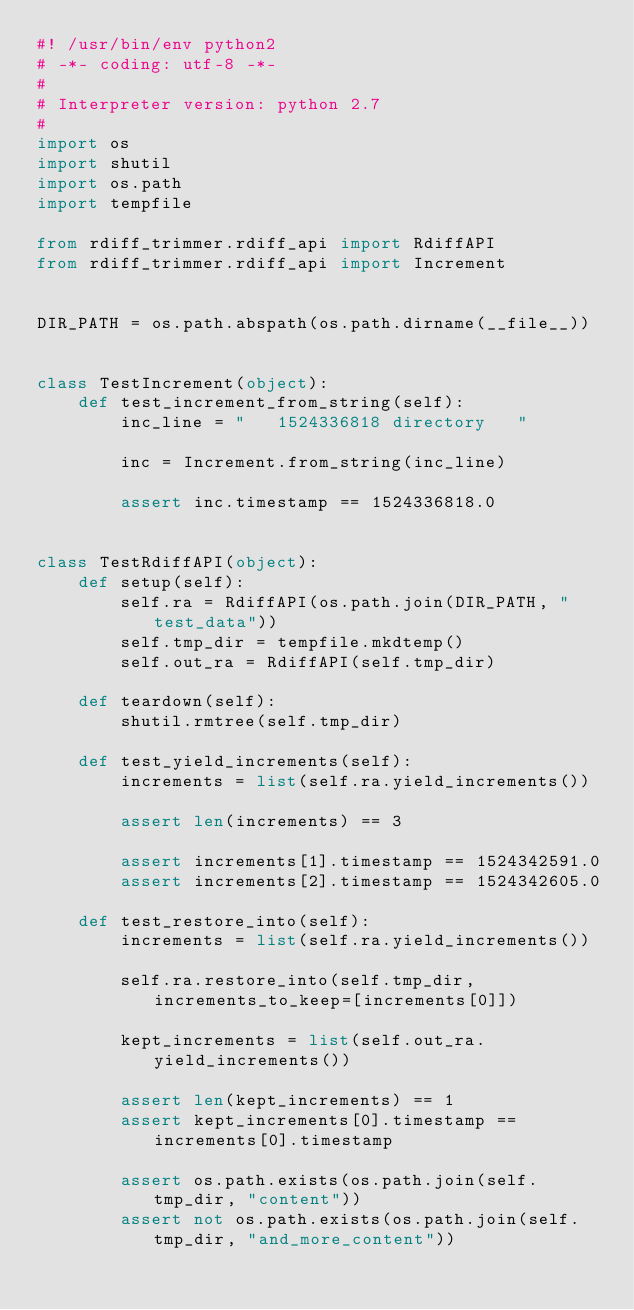<code> <loc_0><loc_0><loc_500><loc_500><_Python_>#! /usr/bin/env python2
# -*- coding: utf-8 -*-
#
# Interpreter version: python 2.7
#
import os
import shutil
import os.path
import tempfile

from rdiff_trimmer.rdiff_api import RdiffAPI
from rdiff_trimmer.rdiff_api import Increment


DIR_PATH = os.path.abspath(os.path.dirname(__file__))


class TestIncrement(object):
    def test_increment_from_string(self):
        inc_line = "   1524336818 directory   "

        inc = Increment.from_string(inc_line)

        assert inc.timestamp == 1524336818.0


class TestRdiffAPI(object):
    def setup(self):
        self.ra = RdiffAPI(os.path.join(DIR_PATH, "test_data"))
        self.tmp_dir = tempfile.mkdtemp()
        self.out_ra = RdiffAPI(self.tmp_dir)

    def teardown(self):
        shutil.rmtree(self.tmp_dir)

    def test_yield_increments(self):
        increments = list(self.ra.yield_increments())

        assert len(increments) == 3

        assert increments[1].timestamp == 1524342591.0
        assert increments[2].timestamp == 1524342605.0

    def test_restore_into(self):
        increments = list(self.ra.yield_increments())

        self.ra.restore_into(self.tmp_dir, increments_to_keep=[increments[0]])

        kept_increments = list(self.out_ra.yield_increments())

        assert len(kept_increments) == 1
        assert kept_increments[0].timestamp == increments[0].timestamp

        assert os.path.exists(os.path.join(self.tmp_dir, "content"))
        assert not os.path.exists(os.path.join(self.tmp_dir, "and_more_content"))
</code> 